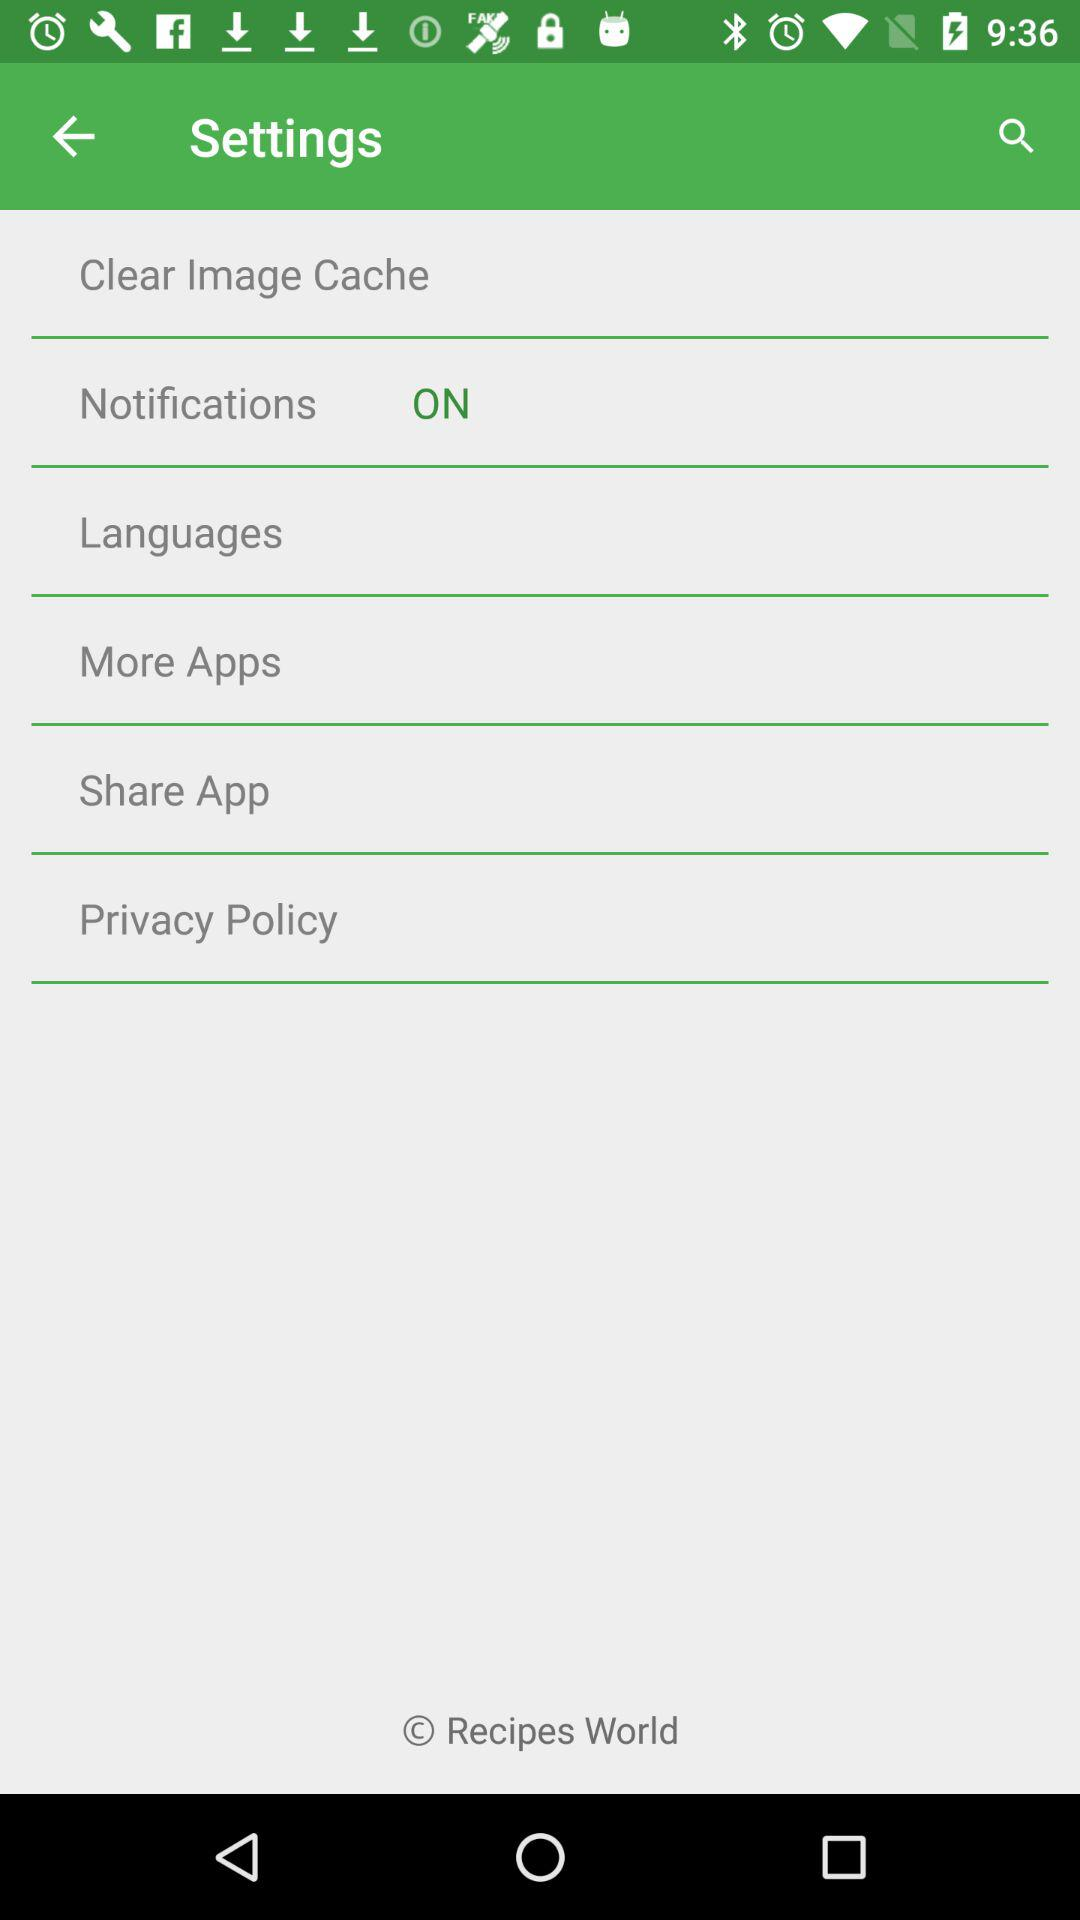What is the status of "Notifications"? The status is "on". 